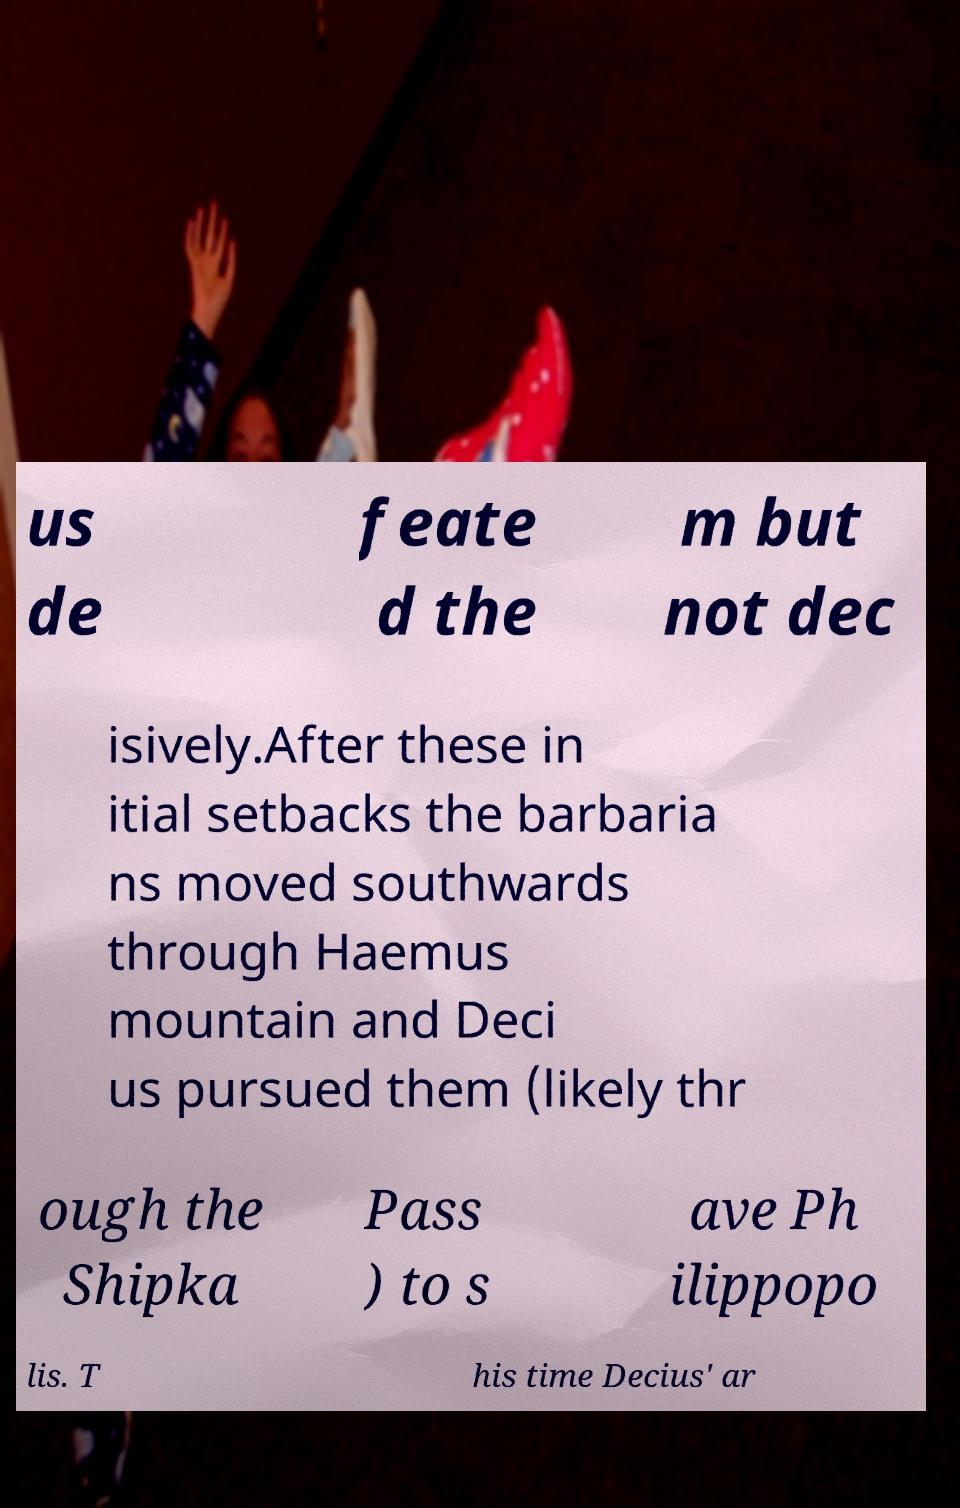Please read and relay the text visible in this image. What does it say? us de feate d the m but not dec isively.After these in itial setbacks the barbaria ns moved southwards through Haemus mountain and Deci us pursued them (likely thr ough the Shipka Pass ) to s ave Ph ilippopo lis. T his time Decius' ar 